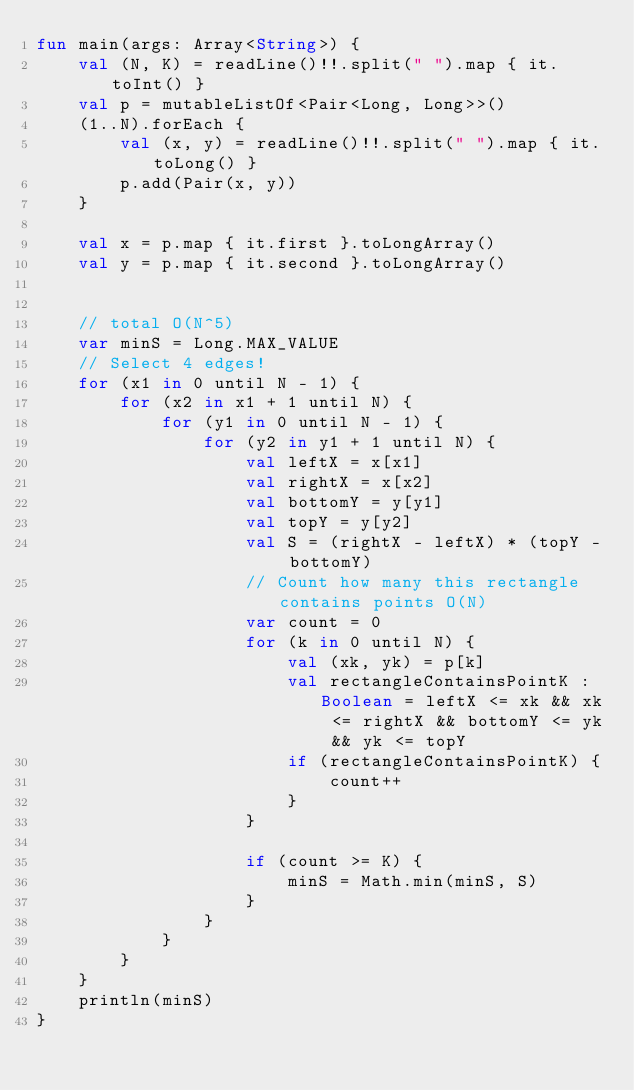<code> <loc_0><loc_0><loc_500><loc_500><_Kotlin_>fun main(args: Array<String>) {
    val (N, K) = readLine()!!.split(" ").map { it.toInt() }
    val p = mutableListOf<Pair<Long, Long>>()
    (1..N).forEach {
        val (x, y) = readLine()!!.split(" ").map { it.toLong() }
        p.add(Pair(x, y))
    }

    val x = p.map { it.first }.toLongArray()
    val y = p.map { it.second }.toLongArray()


    // total O(N^5)
    var minS = Long.MAX_VALUE
    // Select 4 edges!
    for (x1 in 0 until N - 1) {
        for (x2 in x1 + 1 until N) {
            for (y1 in 0 until N - 1) {
                for (y2 in y1 + 1 until N) {
                    val leftX = x[x1]
                    val rightX = x[x2]
                    val bottomY = y[y1]
                    val topY = y[y2]
                    val S = (rightX - leftX) * (topY - bottomY)
                    // Count how many this rectangle contains points O(N)
                    var count = 0
                    for (k in 0 until N) {
                        val (xk, yk) = p[k]
                        val rectangleContainsPointK : Boolean = leftX <= xk && xk <= rightX && bottomY <= yk && yk <= topY
                        if (rectangleContainsPointK) {
                            count++
                        }
                    }

                    if (count >= K) {
                        minS = Math.min(minS, S)
                    }
                }
            }
        }
    }
    println(minS)
}
</code> 